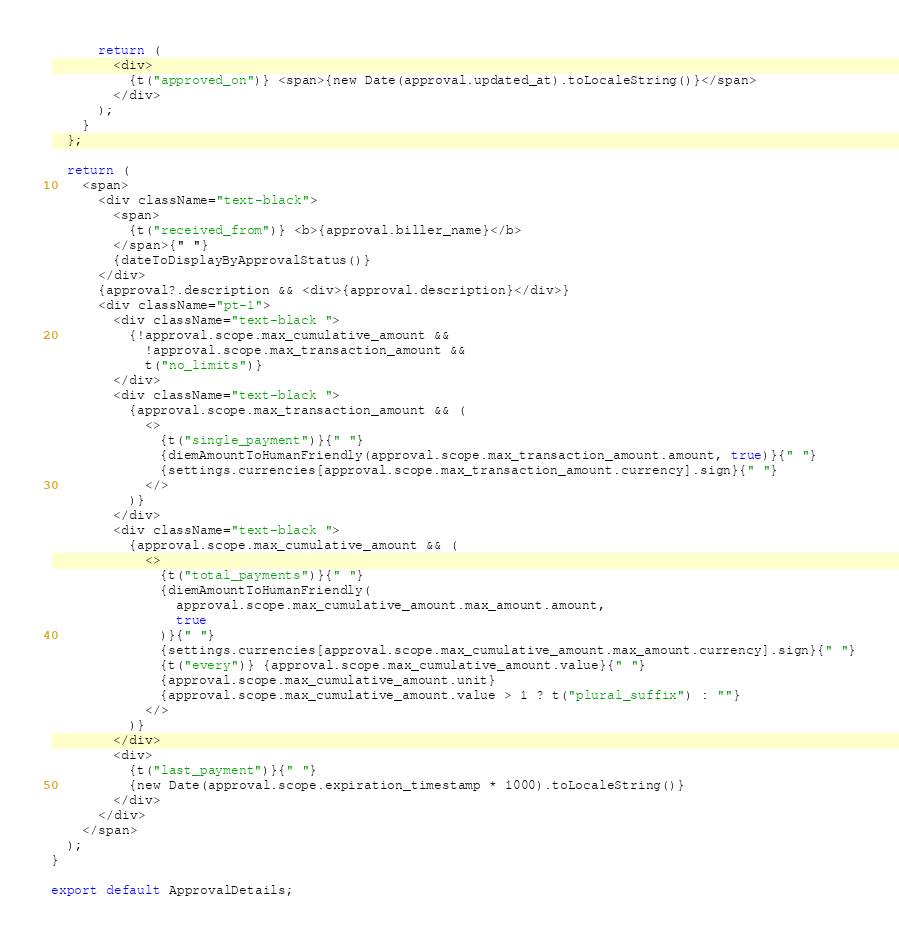<code> <loc_0><loc_0><loc_500><loc_500><_TypeScript_>      return (
        <div>
          {t("approved_on")} <span>{new Date(approval.updated_at).toLocaleString()}</span>
        </div>
      );
    }
  };

  return (
    <span>
      <div className="text-black">
        <span>
          {t("received_from")} <b>{approval.biller_name}</b>
        </span>{" "}
        {dateToDisplayByApprovalStatus()}
      </div>
      {approval?.description && <div>{approval.description}</div>}
      <div className="pt-1">
        <div className="text-black ">
          {!approval.scope.max_cumulative_amount &&
            !approval.scope.max_transaction_amount &&
            t("no_limits")}
        </div>
        <div className="text-black ">
          {approval.scope.max_transaction_amount && (
            <>
              {t("single_payment")}{" "}
              {diemAmountToHumanFriendly(approval.scope.max_transaction_amount.amount, true)}{" "}
              {settings.currencies[approval.scope.max_transaction_amount.currency].sign}{" "}
            </>
          )}
        </div>
        <div className="text-black ">
          {approval.scope.max_cumulative_amount && (
            <>
              {t("total_payments")}{" "}
              {diemAmountToHumanFriendly(
                approval.scope.max_cumulative_amount.max_amount.amount,
                true
              )}{" "}
              {settings.currencies[approval.scope.max_cumulative_amount.max_amount.currency].sign}{" "}
              {t("every")} {approval.scope.max_cumulative_amount.value}{" "}
              {approval.scope.max_cumulative_amount.unit}
              {approval.scope.max_cumulative_amount.value > 1 ? t("plural_suffix") : ""}
            </>
          )}
        </div>
        <div>
          {t("last_payment")}{" "}
          {new Date(approval.scope.expiration_timestamp * 1000).toLocaleString()}
        </div>
      </div>
    </span>
  );
}

export default ApprovalDetails;
</code> 